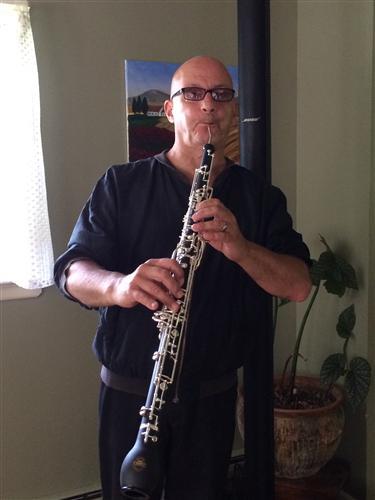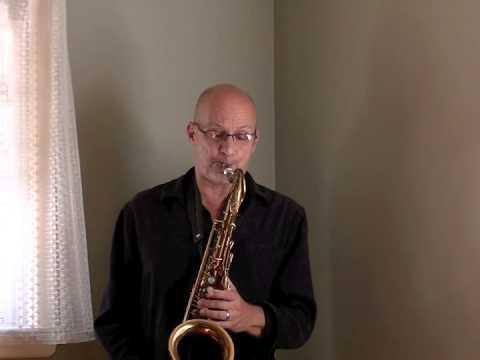The first image is the image on the left, the second image is the image on the right. For the images shown, is this caption "The man is playing the alto sax and has it to his mouth in both of the images." true? Answer yes or no. Yes. The first image is the image on the left, the second image is the image on the right. Examine the images to the left and right. Is the description "Each image shows a man with the mouthpiece of a brass-colored saxophone in his mouth." accurate? Answer yes or no. No. 